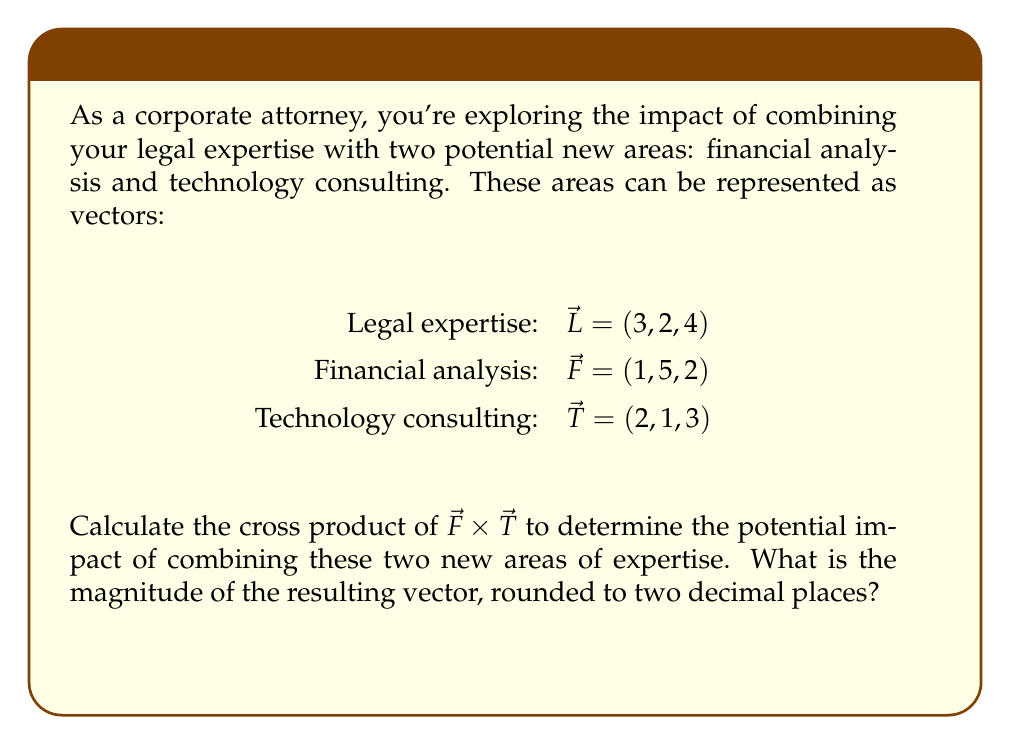What is the answer to this math problem? Let's approach this step-by-step:

1) The cross product of two vectors $\vec{a} = (a_1, a_2, a_3)$ and $\vec{b} = (b_1, b_2, b_3)$ is defined as:

   $\vec{a} \times \vec{b} = (a_2b_3 - a_3b_2, a_3b_1 - a_1b_3, a_1b_2 - a_2b_1)$

2) In our case, $\vec{F} = (1, 5, 2)$ and $\vec{T} = (2, 1, 3)$

3) Let's calculate each component:
   
   $i: (5)(3) - (2)(1) = 15 - 2 = 13$
   $j: (2)(2) - (1)(3) = 4 - 3 = 1$
   $k: (1)(1) - (5)(2) = 1 - 10 = -9$

4) Therefore, $\vec{F} \times \vec{T} = (13, 1, -9)$

5) To find the magnitude of this vector, we use the formula:

   $\|\vec{v}\| = \sqrt{x^2 + y^2 + z^2}$

6) Substituting our values:

   $\|\vec{F} \times \vec{T}\| = \sqrt{13^2 + 1^2 + (-9)^2}$

7) Simplifying:

   $\|\vec{F} \times \vec{T}\| = \sqrt{169 + 1 + 81} = \sqrt{251}$

8) Using a calculator and rounding to two decimal places:

   $\sqrt{251} \approx 15.84$

This magnitude represents the potential impact of combining financial analysis and technology consulting expertise in your legal career.
Answer: $15.84$ 